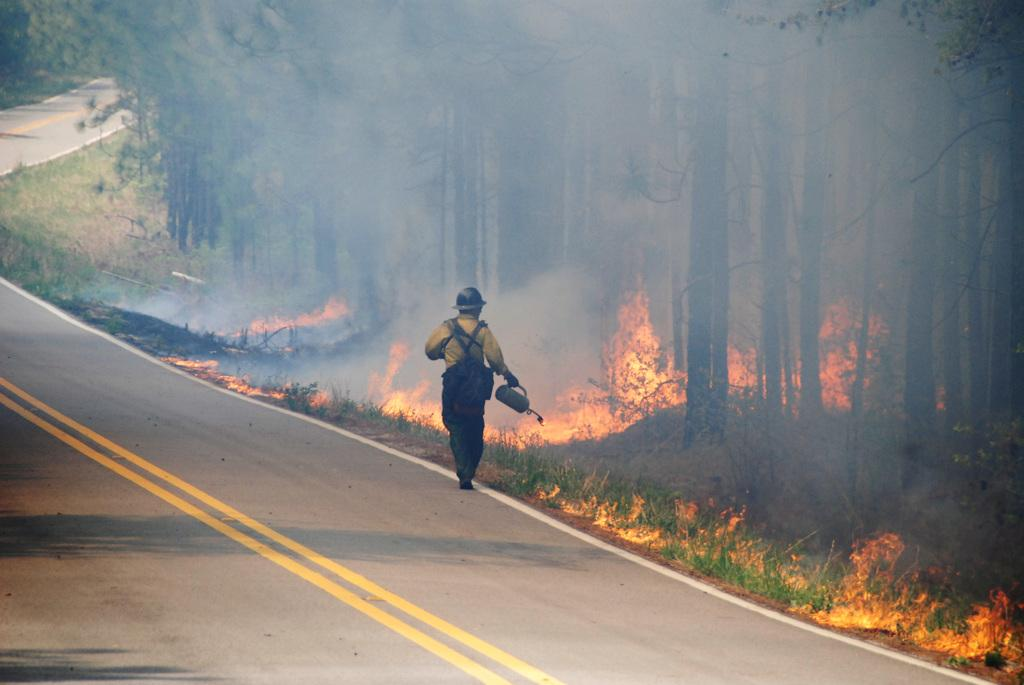What is happening in the image? There is a person in the image who is walking on the road. What is the person holding? The person is holding an object. What can be seen beside the person? There is grass and trees beside the person. What is happening in the grass and trees area? There is a fire in the middle of the grass and trees. What type of arm support is visible in the image? There is no arm support present in the image. What is the stove used for in the image? There is no stove present in the image. 